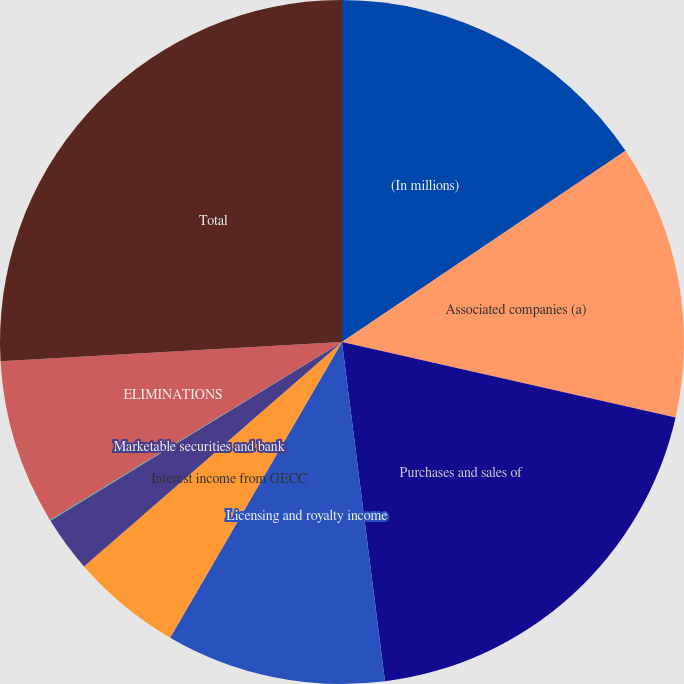Convert chart. <chart><loc_0><loc_0><loc_500><loc_500><pie_chart><fcel>(In millions)<fcel>Associated companies (a)<fcel>Purchases and sales of<fcel>Licensing and royalty income<fcel>Interest income from GECC<fcel>Marketable securities and bank<fcel>Other items<fcel>ELIMINATIONS<fcel>Total<nl><fcel>15.56%<fcel>12.98%<fcel>19.46%<fcel>10.39%<fcel>5.22%<fcel>2.64%<fcel>0.05%<fcel>7.81%<fcel>25.9%<nl></chart> 